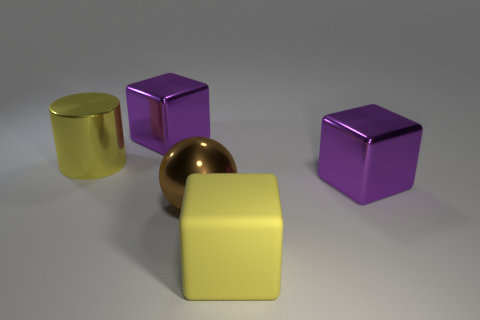How many blue cubes have the same material as the ball?
Ensure brevity in your answer.  0. What size is the yellow metal cylinder behind the big yellow object in front of the big purple shiny cube that is right of the yellow rubber cube?
Make the answer very short. Large. How many big brown metallic spheres are in front of the large yellow metallic thing?
Your answer should be compact. 1. Are there more big yellow rubber cubes than blue blocks?
Keep it short and to the point. Yes. What is the size of the rubber block that is the same color as the metallic cylinder?
Provide a short and direct response. Large. There is a shiny object that is in front of the big yellow shiny cylinder and on the left side of the matte thing; what size is it?
Offer a terse response. Large. What is the purple object left of the brown shiny thing that is to the left of the purple shiny thing that is in front of the large yellow cylinder made of?
Your answer should be compact. Metal. There is a cylinder that is the same color as the rubber thing; what is its material?
Offer a very short reply. Metal. There is a block in front of the brown shiny sphere; is its color the same as the metallic object that is behind the yellow metal object?
Offer a very short reply. No. There is a yellow thing that is behind the large purple object that is in front of the purple shiny thing that is behind the big yellow shiny cylinder; what is its shape?
Your response must be concise. Cylinder. 